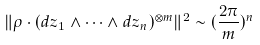<formula> <loc_0><loc_0><loc_500><loc_500>\| \rho \cdot ( d z _ { 1 } \wedge \cdots \wedge d z _ { n } ) ^ { \otimes m } \| ^ { 2 } \sim ( \frac { 2 \pi } { m } ) ^ { n }</formula> 